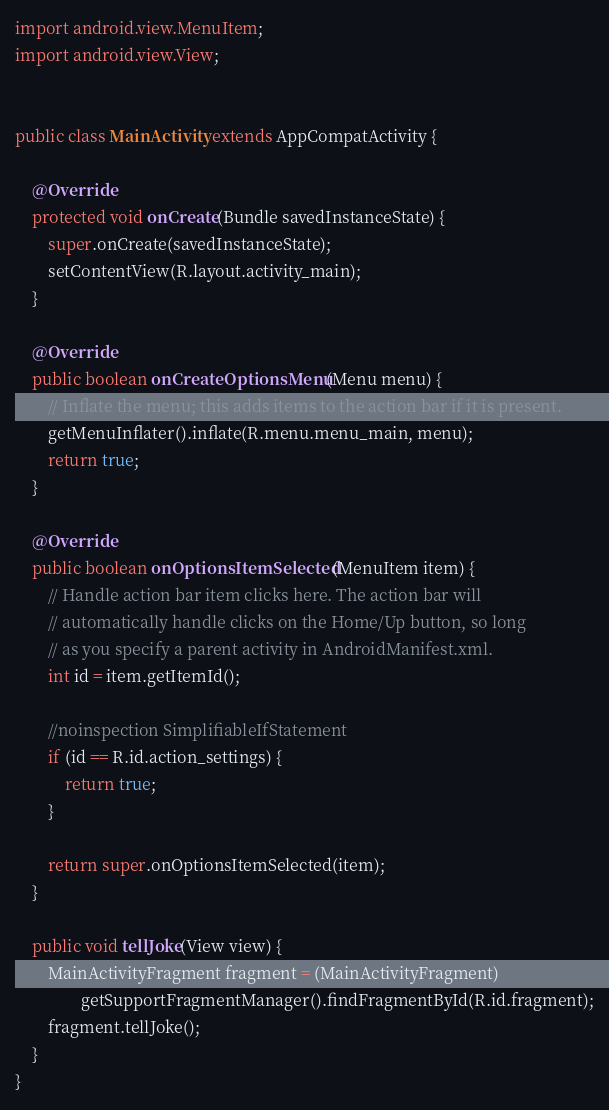Convert code to text. <code><loc_0><loc_0><loc_500><loc_500><_Java_>import android.view.MenuItem;
import android.view.View;


public class MainActivity extends AppCompatActivity {

    @Override
    protected void onCreate(Bundle savedInstanceState) {
        super.onCreate(savedInstanceState);
        setContentView(R.layout.activity_main);
    }

    @Override
    public boolean onCreateOptionsMenu(Menu menu) {
        // Inflate the menu; this adds items to the action bar if it is present.
        getMenuInflater().inflate(R.menu.menu_main, menu);
        return true;
    }

    @Override
    public boolean onOptionsItemSelected(MenuItem item) {
        // Handle action bar item clicks here. The action bar will
        // automatically handle clicks on the Home/Up button, so long
        // as you specify a parent activity in AndroidManifest.xml.
        int id = item.getItemId();

        //noinspection SimplifiableIfStatement
        if (id == R.id.action_settings) {
            return true;
        }

        return super.onOptionsItemSelected(item);
    }

    public void tellJoke(View view) {
        MainActivityFragment fragment = (MainActivityFragment)
                getSupportFragmentManager().findFragmentById(R.id.fragment);
        fragment.tellJoke();
    }
}
</code> 